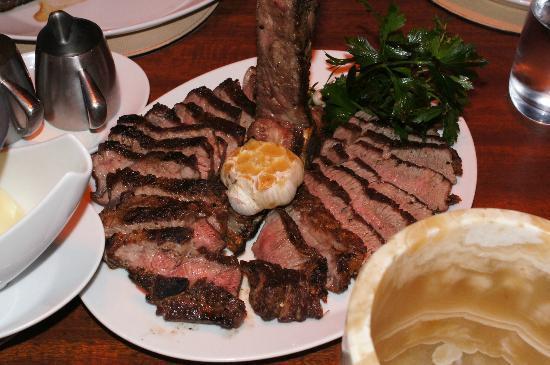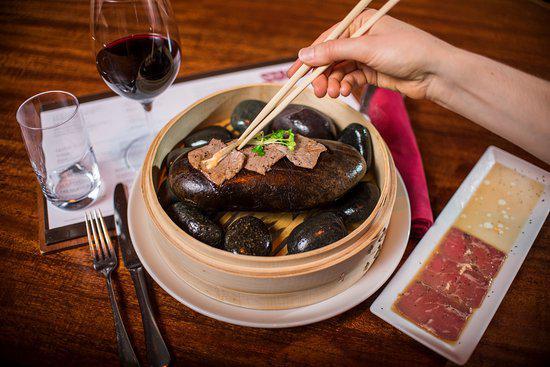The first image is the image on the left, the second image is the image on the right. For the images shown, is this caption "there is sliced steak on a white oval plate, there is roasted garlic and greens on the plate and next to the plate is a silver teapot" true? Answer yes or no. Yes. The first image is the image on the left, the second image is the image on the right. Analyze the images presented: Is the assertion "In at least one image there is a bamboo bowl holding hot stones and topped with chopsticks." valid? Answer yes or no. Yes. 